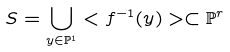Convert formula to latex. <formula><loc_0><loc_0><loc_500><loc_500>S = \bigcup _ { y \in { \mathbb { P } } ^ { 1 } } < f ^ { - 1 } ( y ) > \subset { \mathbb { P } } ^ { r }</formula> 